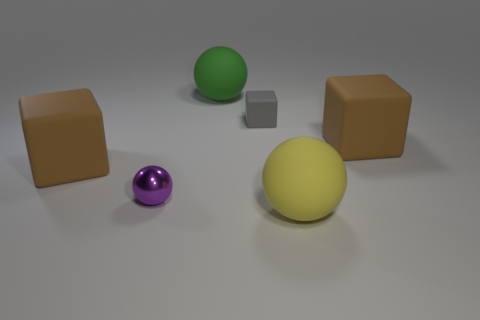Add 3 yellow rubber objects. How many objects exist? 9 Add 6 gray matte things. How many gray matte things are left? 7 Add 5 large green things. How many large green things exist? 6 Subtract 0 brown spheres. How many objects are left? 6 Subtract all tiny purple objects. Subtract all small purple objects. How many objects are left? 4 